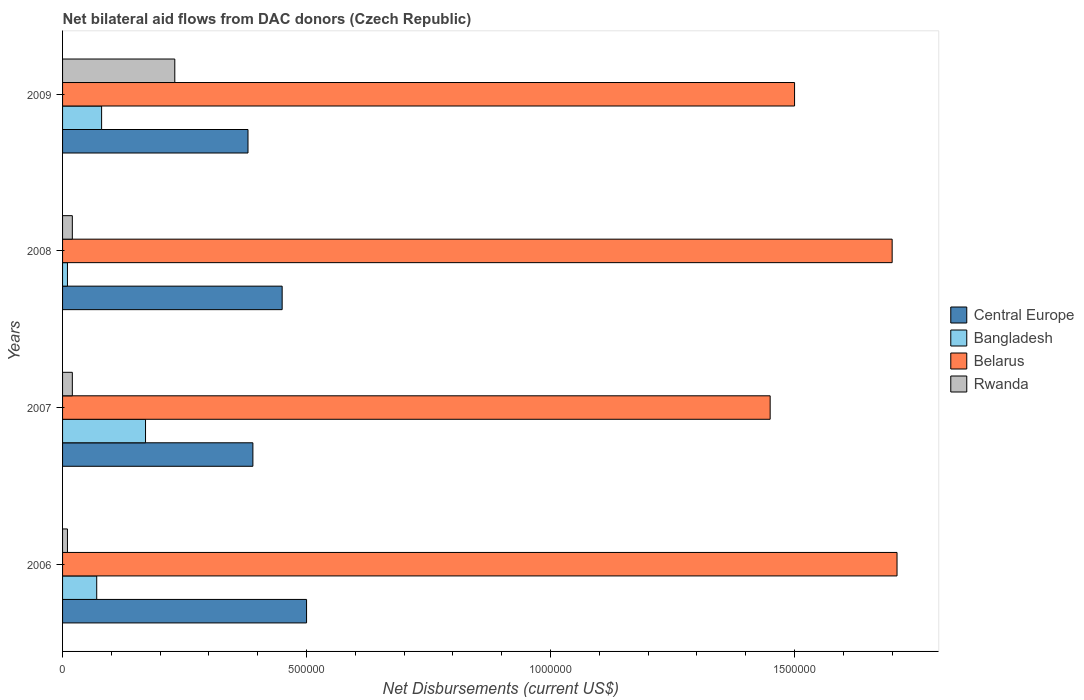How many different coloured bars are there?
Provide a succinct answer. 4. Are the number of bars on each tick of the Y-axis equal?
Ensure brevity in your answer.  Yes. How many bars are there on the 2nd tick from the top?
Offer a very short reply. 4. How many bars are there on the 4th tick from the bottom?
Provide a succinct answer. 4. In how many cases, is the number of bars for a given year not equal to the number of legend labels?
Give a very brief answer. 0. Across all years, what is the maximum net bilateral aid flows in Belarus?
Make the answer very short. 1.71e+06. What is the total net bilateral aid flows in Belarus in the graph?
Your response must be concise. 6.36e+06. What is the difference between the net bilateral aid flows in Belarus in 2006 and the net bilateral aid flows in Central Europe in 2008?
Your answer should be compact. 1.26e+06. In the year 2007, what is the difference between the net bilateral aid flows in Central Europe and net bilateral aid flows in Rwanda?
Your answer should be compact. 3.70e+05. What is the ratio of the net bilateral aid flows in Bangladesh in 2006 to that in 2007?
Provide a succinct answer. 0.41. Is the difference between the net bilateral aid flows in Central Europe in 2008 and 2009 greater than the difference between the net bilateral aid flows in Rwanda in 2008 and 2009?
Provide a short and direct response. Yes. What does the 2nd bar from the top in 2009 represents?
Provide a short and direct response. Belarus. What does the 3rd bar from the bottom in 2006 represents?
Ensure brevity in your answer.  Belarus. Is it the case that in every year, the sum of the net bilateral aid flows in Belarus and net bilateral aid flows in Central Europe is greater than the net bilateral aid flows in Rwanda?
Make the answer very short. Yes. How many years are there in the graph?
Keep it short and to the point. 4. What is the difference between two consecutive major ticks on the X-axis?
Make the answer very short. 5.00e+05. Does the graph contain grids?
Offer a terse response. No. Where does the legend appear in the graph?
Your answer should be very brief. Center right. How many legend labels are there?
Your answer should be very brief. 4. How are the legend labels stacked?
Keep it short and to the point. Vertical. What is the title of the graph?
Your response must be concise. Net bilateral aid flows from DAC donors (Czech Republic). What is the label or title of the X-axis?
Provide a succinct answer. Net Disbursements (current US$). What is the Net Disbursements (current US$) of Central Europe in 2006?
Make the answer very short. 5.00e+05. What is the Net Disbursements (current US$) of Bangladesh in 2006?
Provide a succinct answer. 7.00e+04. What is the Net Disbursements (current US$) in Belarus in 2006?
Offer a terse response. 1.71e+06. What is the Net Disbursements (current US$) in Rwanda in 2006?
Your answer should be compact. 10000. What is the Net Disbursements (current US$) in Central Europe in 2007?
Make the answer very short. 3.90e+05. What is the Net Disbursements (current US$) of Bangladesh in 2007?
Give a very brief answer. 1.70e+05. What is the Net Disbursements (current US$) of Belarus in 2007?
Your response must be concise. 1.45e+06. What is the Net Disbursements (current US$) in Belarus in 2008?
Your answer should be very brief. 1.70e+06. What is the Net Disbursements (current US$) in Central Europe in 2009?
Your answer should be compact. 3.80e+05. What is the Net Disbursements (current US$) of Bangladesh in 2009?
Your answer should be very brief. 8.00e+04. What is the Net Disbursements (current US$) of Belarus in 2009?
Provide a short and direct response. 1.50e+06. Across all years, what is the maximum Net Disbursements (current US$) of Central Europe?
Your answer should be compact. 5.00e+05. Across all years, what is the maximum Net Disbursements (current US$) of Bangladesh?
Make the answer very short. 1.70e+05. Across all years, what is the maximum Net Disbursements (current US$) of Belarus?
Provide a short and direct response. 1.71e+06. Across all years, what is the minimum Net Disbursements (current US$) in Belarus?
Keep it short and to the point. 1.45e+06. Across all years, what is the minimum Net Disbursements (current US$) in Rwanda?
Give a very brief answer. 10000. What is the total Net Disbursements (current US$) in Central Europe in the graph?
Offer a very short reply. 1.72e+06. What is the total Net Disbursements (current US$) of Belarus in the graph?
Offer a terse response. 6.36e+06. What is the total Net Disbursements (current US$) in Rwanda in the graph?
Provide a short and direct response. 2.80e+05. What is the difference between the Net Disbursements (current US$) in Bangladesh in 2006 and that in 2007?
Your answer should be very brief. -1.00e+05. What is the difference between the Net Disbursements (current US$) in Central Europe in 2006 and that in 2009?
Provide a succinct answer. 1.20e+05. What is the difference between the Net Disbursements (current US$) of Bangladesh in 2006 and that in 2009?
Give a very brief answer. -10000. What is the difference between the Net Disbursements (current US$) in Belarus in 2006 and that in 2009?
Offer a terse response. 2.10e+05. What is the difference between the Net Disbursements (current US$) in Rwanda in 2006 and that in 2009?
Offer a very short reply. -2.20e+05. What is the difference between the Net Disbursements (current US$) of Central Europe in 2007 and that in 2008?
Give a very brief answer. -6.00e+04. What is the difference between the Net Disbursements (current US$) in Belarus in 2007 and that in 2008?
Provide a short and direct response. -2.50e+05. What is the difference between the Net Disbursements (current US$) of Bangladesh in 2007 and that in 2009?
Ensure brevity in your answer.  9.00e+04. What is the difference between the Net Disbursements (current US$) of Belarus in 2008 and that in 2009?
Ensure brevity in your answer.  2.00e+05. What is the difference between the Net Disbursements (current US$) of Central Europe in 2006 and the Net Disbursements (current US$) of Bangladesh in 2007?
Make the answer very short. 3.30e+05. What is the difference between the Net Disbursements (current US$) of Central Europe in 2006 and the Net Disbursements (current US$) of Belarus in 2007?
Offer a very short reply. -9.50e+05. What is the difference between the Net Disbursements (current US$) in Central Europe in 2006 and the Net Disbursements (current US$) in Rwanda in 2007?
Ensure brevity in your answer.  4.80e+05. What is the difference between the Net Disbursements (current US$) of Bangladesh in 2006 and the Net Disbursements (current US$) of Belarus in 2007?
Give a very brief answer. -1.38e+06. What is the difference between the Net Disbursements (current US$) of Bangladesh in 2006 and the Net Disbursements (current US$) of Rwanda in 2007?
Offer a very short reply. 5.00e+04. What is the difference between the Net Disbursements (current US$) of Belarus in 2006 and the Net Disbursements (current US$) of Rwanda in 2007?
Give a very brief answer. 1.69e+06. What is the difference between the Net Disbursements (current US$) of Central Europe in 2006 and the Net Disbursements (current US$) of Bangladesh in 2008?
Your answer should be compact. 4.90e+05. What is the difference between the Net Disbursements (current US$) of Central Europe in 2006 and the Net Disbursements (current US$) of Belarus in 2008?
Provide a short and direct response. -1.20e+06. What is the difference between the Net Disbursements (current US$) in Central Europe in 2006 and the Net Disbursements (current US$) in Rwanda in 2008?
Give a very brief answer. 4.80e+05. What is the difference between the Net Disbursements (current US$) of Bangladesh in 2006 and the Net Disbursements (current US$) of Belarus in 2008?
Provide a succinct answer. -1.63e+06. What is the difference between the Net Disbursements (current US$) of Belarus in 2006 and the Net Disbursements (current US$) of Rwanda in 2008?
Keep it short and to the point. 1.69e+06. What is the difference between the Net Disbursements (current US$) in Central Europe in 2006 and the Net Disbursements (current US$) in Bangladesh in 2009?
Your answer should be compact. 4.20e+05. What is the difference between the Net Disbursements (current US$) in Bangladesh in 2006 and the Net Disbursements (current US$) in Belarus in 2009?
Give a very brief answer. -1.43e+06. What is the difference between the Net Disbursements (current US$) of Belarus in 2006 and the Net Disbursements (current US$) of Rwanda in 2009?
Provide a short and direct response. 1.48e+06. What is the difference between the Net Disbursements (current US$) in Central Europe in 2007 and the Net Disbursements (current US$) in Bangladesh in 2008?
Your response must be concise. 3.80e+05. What is the difference between the Net Disbursements (current US$) of Central Europe in 2007 and the Net Disbursements (current US$) of Belarus in 2008?
Give a very brief answer. -1.31e+06. What is the difference between the Net Disbursements (current US$) of Bangladesh in 2007 and the Net Disbursements (current US$) of Belarus in 2008?
Your answer should be compact. -1.53e+06. What is the difference between the Net Disbursements (current US$) in Belarus in 2007 and the Net Disbursements (current US$) in Rwanda in 2008?
Your answer should be very brief. 1.43e+06. What is the difference between the Net Disbursements (current US$) in Central Europe in 2007 and the Net Disbursements (current US$) in Bangladesh in 2009?
Your answer should be compact. 3.10e+05. What is the difference between the Net Disbursements (current US$) in Central Europe in 2007 and the Net Disbursements (current US$) in Belarus in 2009?
Offer a terse response. -1.11e+06. What is the difference between the Net Disbursements (current US$) in Bangladesh in 2007 and the Net Disbursements (current US$) in Belarus in 2009?
Make the answer very short. -1.33e+06. What is the difference between the Net Disbursements (current US$) in Bangladesh in 2007 and the Net Disbursements (current US$) in Rwanda in 2009?
Keep it short and to the point. -6.00e+04. What is the difference between the Net Disbursements (current US$) of Belarus in 2007 and the Net Disbursements (current US$) of Rwanda in 2009?
Offer a terse response. 1.22e+06. What is the difference between the Net Disbursements (current US$) of Central Europe in 2008 and the Net Disbursements (current US$) of Belarus in 2009?
Keep it short and to the point. -1.05e+06. What is the difference between the Net Disbursements (current US$) in Central Europe in 2008 and the Net Disbursements (current US$) in Rwanda in 2009?
Offer a terse response. 2.20e+05. What is the difference between the Net Disbursements (current US$) in Bangladesh in 2008 and the Net Disbursements (current US$) in Belarus in 2009?
Provide a short and direct response. -1.49e+06. What is the difference between the Net Disbursements (current US$) in Bangladesh in 2008 and the Net Disbursements (current US$) in Rwanda in 2009?
Offer a very short reply. -2.20e+05. What is the difference between the Net Disbursements (current US$) in Belarus in 2008 and the Net Disbursements (current US$) in Rwanda in 2009?
Provide a succinct answer. 1.47e+06. What is the average Net Disbursements (current US$) in Bangladesh per year?
Provide a succinct answer. 8.25e+04. What is the average Net Disbursements (current US$) of Belarus per year?
Offer a very short reply. 1.59e+06. What is the average Net Disbursements (current US$) of Rwanda per year?
Your answer should be compact. 7.00e+04. In the year 2006, what is the difference between the Net Disbursements (current US$) of Central Europe and Net Disbursements (current US$) of Bangladesh?
Provide a short and direct response. 4.30e+05. In the year 2006, what is the difference between the Net Disbursements (current US$) of Central Europe and Net Disbursements (current US$) of Belarus?
Provide a short and direct response. -1.21e+06. In the year 2006, what is the difference between the Net Disbursements (current US$) of Bangladesh and Net Disbursements (current US$) of Belarus?
Ensure brevity in your answer.  -1.64e+06. In the year 2006, what is the difference between the Net Disbursements (current US$) in Bangladesh and Net Disbursements (current US$) in Rwanda?
Provide a succinct answer. 6.00e+04. In the year 2006, what is the difference between the Net Disbursements (current US$) of Belarus and Net Disbursements (current US$) of Rwanda?
Make the answer very short. 1.70e+06. In the year 2007, what is the difference between the Net Disbursements (current US$) of Central Europe and Net Disbursements (current US$) of Bangladesh?
Give a very brief answer. 2.20e+05. In the year 2007, what is the difference between the Net Disbursements (current US$) in Central Europe and Net Disbursements (current US$) in Belarus?
Keep it short and to the point. -1.06e+06. In the year 2007, what is the difference between the Net Disbursements (current US$) in Bangladesh and Net Disbursements (current US$) in Belarus?
Make the answer very short. -1.28e+06. In the year 2007, what is the difference between the Net Disbursements (current US$) of Belarus and Net Disbursements (current US$) of Rwanda?
Provide a succinct answer. 1.43e+06. In the year 2008, what is the difference between the Net Disbursements (current US$) of Central Europe and Net Disbursements (current US$) of Belarus?
Your response must be concise. -1.25e+06. In the year 2008, what is the difference between the Net Disbursements (current US$) in Bangladesh and Net Disbursements (current US$) in Belarus?
Provide a short and direct response. -1.69e+06. In the year 2008, what is the difference between the Net Disbursements (current US$) of Bangladesh and Net Disbursements (current US$) of Rwanda?
Provide a short and direct response. -10000. In the year 2008, what is the difference between the Net Disbursements (current US$) in Belarus and Net Disbursements (current US$) in Rwanda?
Keep it short and to the point. 1.68e+06. In the year 2009, what is the difference between the Net Disbursements (current US$) in Central Europe and Net Disbursements (current US$) in Belarus?
Ensure brevity in your answer.  -1.12e+06. In the year 2009, what is the difference between the Net Disbursements (current US$) in Bangladesh and Net Disbursements (current US$) in Belarus?
Offer a very short reply. -1.42e+06. In the year 2009, what is the difference between the Net Disbursements (current US$) of Bangladesh and Net Disbursements (current US$) of Rwanda?
Your answer should be very brief. -1.50e+05. In the year 2009, what is the difference between the Net Disbursements (current US$) of Belarus and Net Disbursements (current US$) of Rwanda?
Your answer should be very brief. 1.27e+06. What is the ratio of the Net Disbursements (current US$) of Central Europe in 2006 to that in 2007?
Offer a terse response. 1.28. What is the ratio of the Net Disbursements (current US$) in Bangladesh in 2006 to that in 2007?
Offer a very short reply. 0.41. What is the ratio of the Net Disbursements (current US$) of Belarus in 2006 to that in 2007?
Make the answer very short. 1.18. What is the ratio of the Net Disbursements (current US$) of Central Europe in 2006 to that in 2008?
Provide a short and direct response. 1.11. What is the ratio of the Net Disbursements (current US$) in Bangladesh in 2006 to that in 2008?
Your answer should be compact. 7. What is the ratio of the Net Disbursements (current US$) of Belarus in 2006 to that in 2008?
Give a very brief answer. 1.01. What is the ratio of the Net Disbursements (current US$) in Rwanda in 2006 to that in 2008?
Your response must be concise. 0.5. What is the ratio of the Net Disbursements (current US$) of Central Europe in 2006 to that in 2009?
Give a very brief answer. 1.32. What is the ratio of the Net Disbursements (current US$) in Bangladesh in 2006 to that in 2009?
Provide a succinct answer. 0.88. What is the ratio of the Net Disbursements (current US$) of Belarus in 2006 to that in 2009?
Your response must be concise. 1.14. What is the ratio of the Net Disbursements (current US$) in Rwanda in 2006 to that in 2009?
Give a very brief answer. 0.04. What is the ratio of the Net Disbursements (current US$) of Central Europe in 2007 to that in 2008?
Your answer should be very brief. 0.87. What is the ratio of the Net Disbursements (current US$) in Bangladesh in 2007 to that in 2008?
Offer a terse response. 17. What is the ratio of the Net Disbursements (current US$) in Belarus in 2007 to that in 2008?
Offer a terse response. 0.85. What is the ratio of the Net Disbursements (current US$) of Rwanda in 2007 to that in 2008?
Provide a succinct answer. 1. What is the ratio of the Net Disbursements (current US$) in Central Europe in 2007 to that in 2009?
Make the answer very short. 1.03. What is the ratio of the Net Disbursements (current US$) in Bangladesh in 2007 to that in 2009?
Ensure brevity in your answer.  2.12. What is the ratio of the Net Disbursements (current US$) in Belarus in 2007 to that in 2009?
Provide a succinct answer. 0.97. What is the ratio of the Net Disbursements (current US$) of Rwanda in 2007 to that in 2009?
Make the answer very short. 0.09. What is the ratio of the Net Disbursements (current US$) of Central Europe in 2008 to that in 2009?
Make the answer very short. 1.18. What is the ratio of the Net Disbursements (current US$) of Belarus in 2008 to that in 2009?
Offer a terse response. 1.13. What is the ratio of the Net Disbursements (current US$) of Rwanda in 2008 to that in 2009?
Ensure brevity in your answer.  0.09. What is the difference between the highest and the second highest Net Disbursements (current US$) in Central Europe?
Your response must be concise. 5.00e+04. What is the difference between the highest and the second highest Net Disbursements (current US$) of Belarus?
Offer a terse response. 10000. What is the difference between the highest and the second highest Net Disbursements (current US$) of Rwanda?
Your answer should be very brief. 2.10e+05. What is the difference between the highest and the lowest Net Disbursements (current US$) in Central Europe?
Offer a very short reply. 1.20e+05. What is the difference between the highest and the lowest Net Disbursements (current US$) in Bangladesh?
Your answer should be very brief. 1.60e+05. 